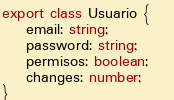<code> <loc_0><loc_0><loc_500><loc_500><_TypeScript_>export class Usuario {
    email: string;
    password: string; 
    permisos: boolean;    
    changes: number;
}</code> 